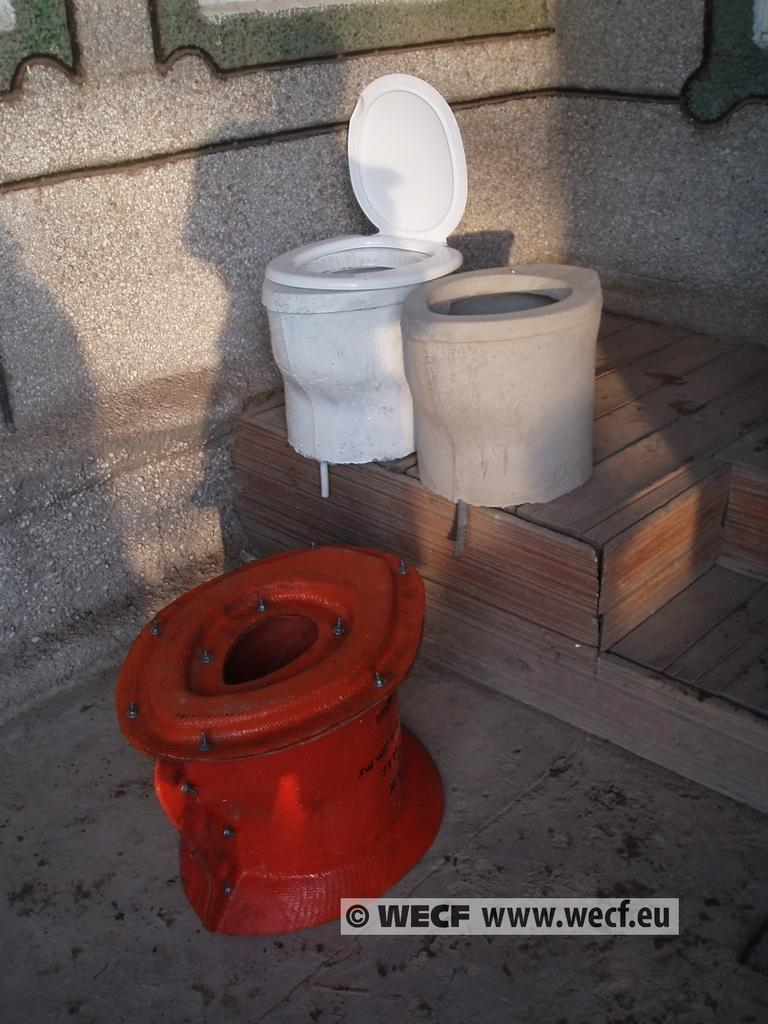<image>
Describe the image concisely. toilets are shown in a photo from www.wecf.eu. 